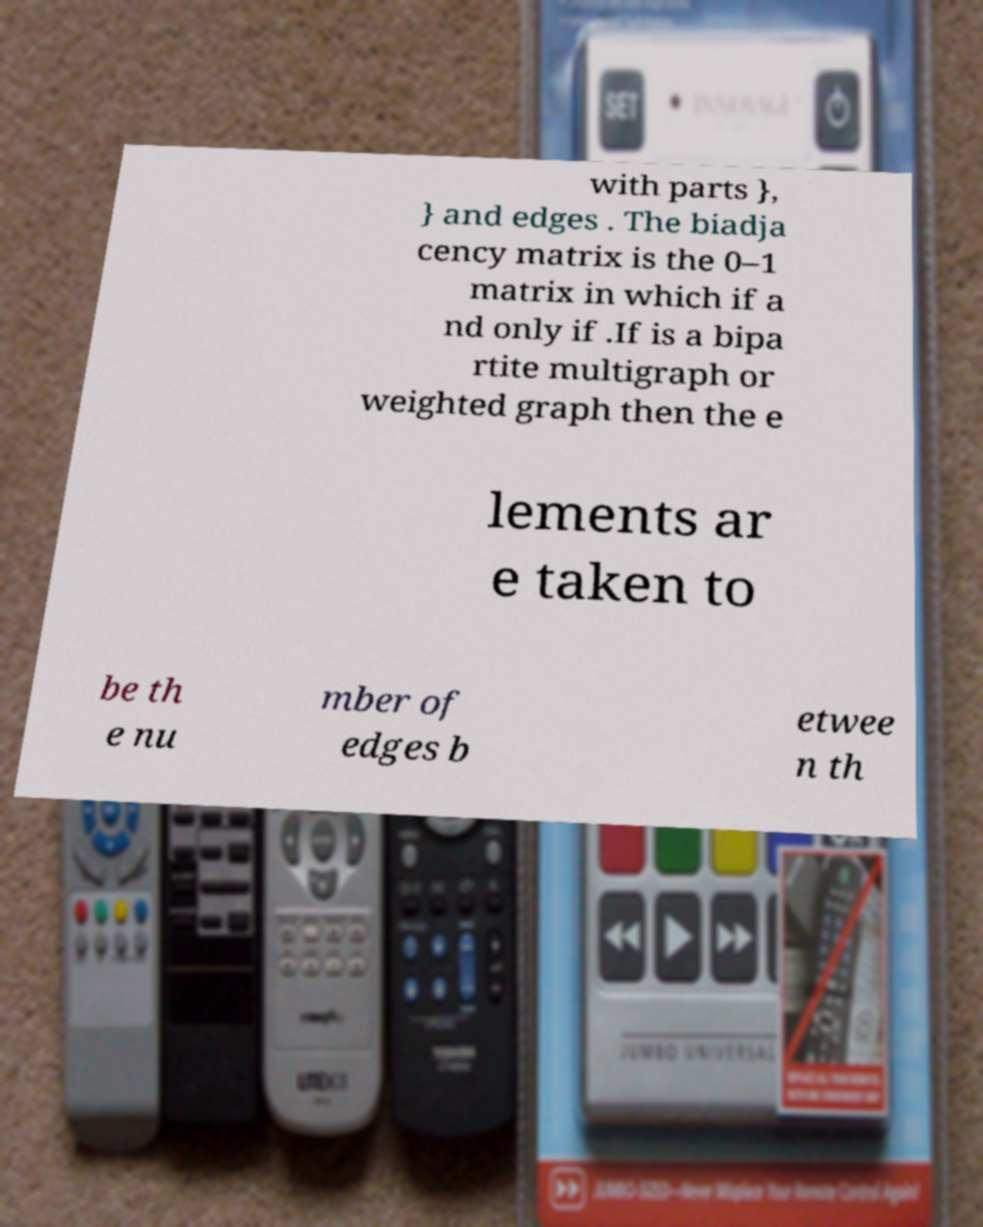Please read and relay the text visible in this image. What does it say? with parts }, } and edges . The biadja cency matrix is the 0–1 matrix in which if a nd only if .If is a bipa rtite multigraph or weighted graph then the e lements ar e taken to be th e nu mber of edges b etwee n th 